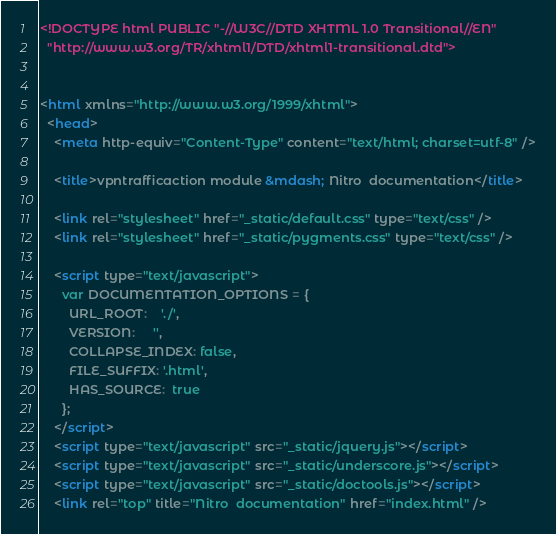Convert code to text. <code><loc_0><loc_0><loc_500><loc_500><_HTML_><!DOCTYPE html PUBLIC "-//W3C//DTD XHTML 1.0 Transitional//EN"
  "http://www.w3.org/TR/xhtml1/DTD/xhtml1-transitional.dtd">


<html xmlns="http://www.w3.org/1999/xhtml">
  <head>
    <meta http-equiv="Content-Type" content="text/html; charset=utf-8" />
    
    <title>vpntrafficaction module &mdash; Nitro  documentation</title>
    
    <link rel="stylesheet" href="_static/default.css" type="text/css" />
    <link rel="stylesheet" href="_static/pygments.css" type="text/css" />
    
    <script type="text/javascript">
      var DOCUMENTATION_OPTIONS = {
        URL_ROOT:    './',
        VERSION:     '',
        COLLAPSE_INDEX: false,
        FILE_SUFFIX: '.html',
        HAS_SOURCE:  true
      };
    </script>
    <script type="text/javascript" src="_static/jquery.js"></script>
    <script type="text/javascript" src="_static/underscore.js"></script>
    <script type="text/javascript" src="_static/doctools.js"></script>
    <link rel="top" title="Nitro  documentation" href="index.html" /></code> 